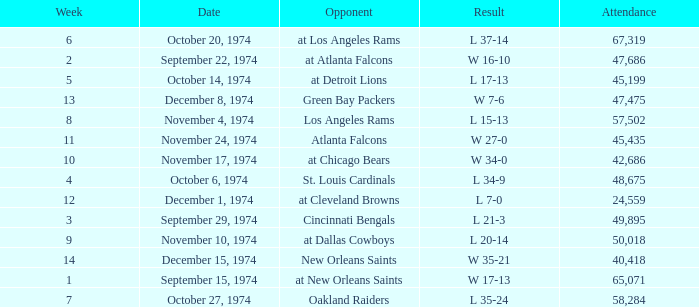Which week was the game played on December 8, 1974? 13.0. 